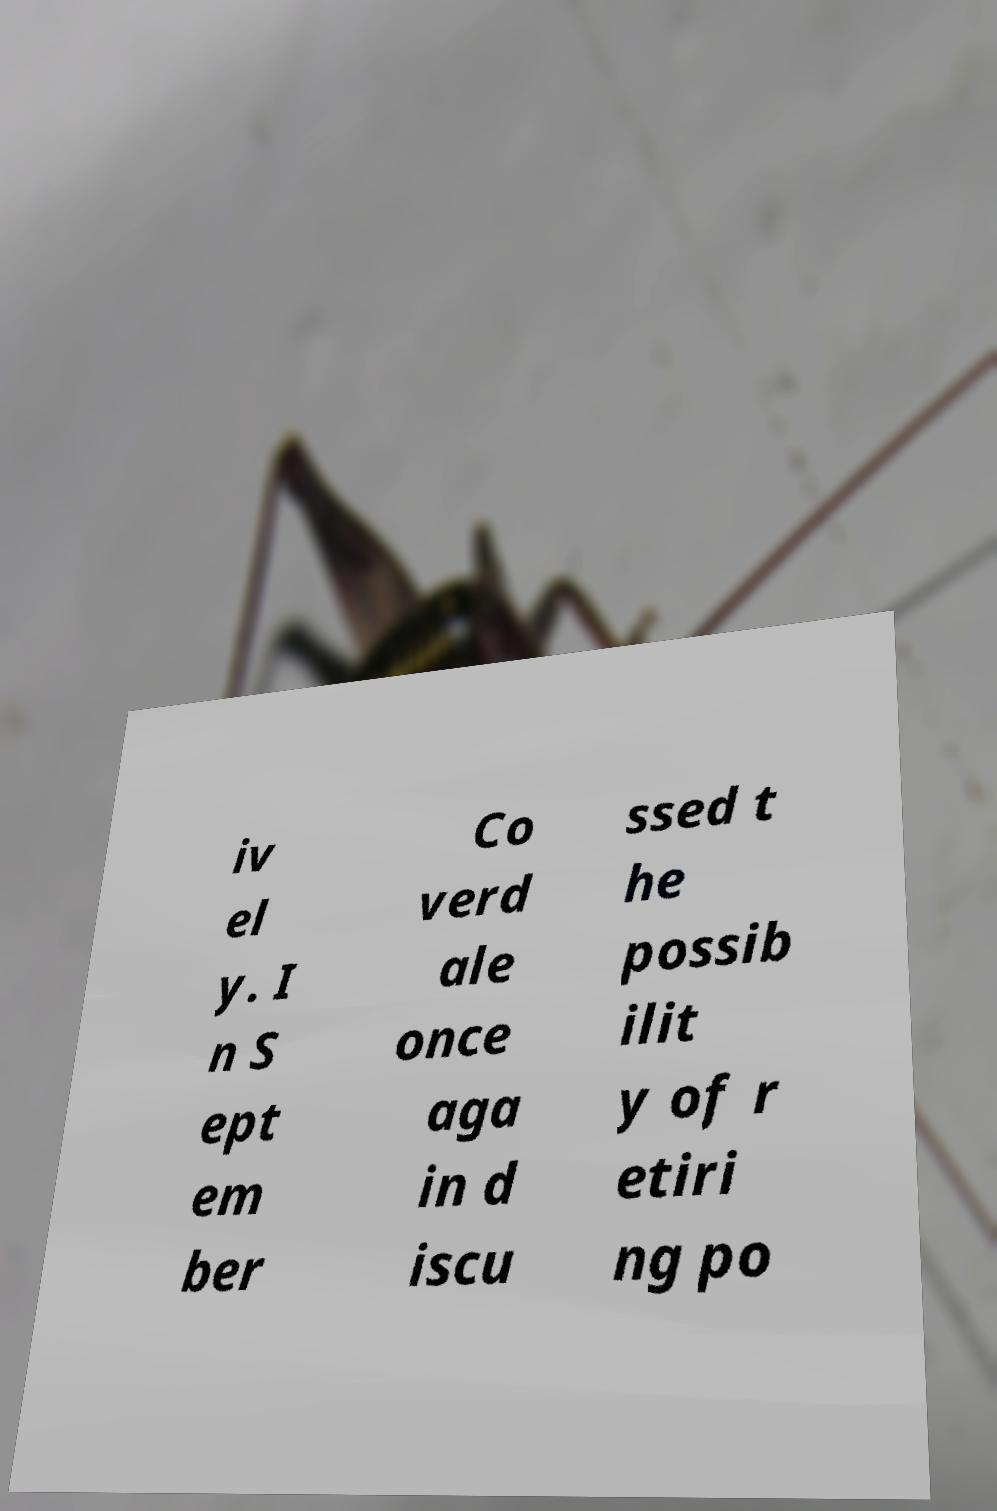Please read and relay the text visible in this image. What does it say? iv el y. I n S ept em ber Co verd ale once aga in d iscu ssed t he possib ilit y of r etiri ng po 